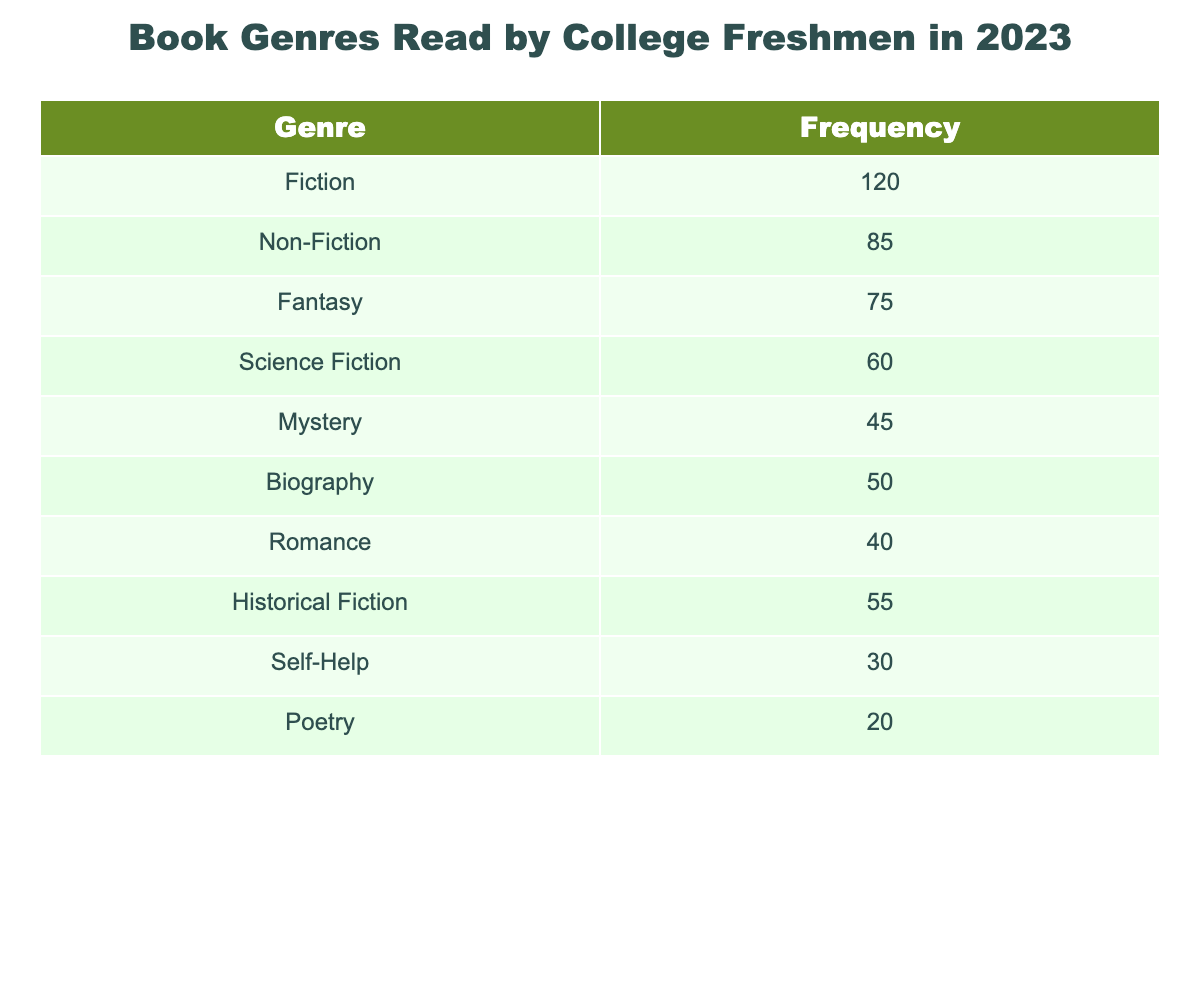What is the most read book genre by college freshmen in 2023? The table indicates that the genre with the highest frequency is Fiction with a total of 120.
Answer: Fiction How many freshmen read Non-Fiction books? The table provides the frequency for Non-Fiction, which is stated to be 85.
Answer: 85 Which genre has the lowest frequency of readers? From the table, Poetry has the lowest frequency of readers, with a total of 20.
Answer: Poetry What is the total number of freshmen that read Fiction and Mystery combined? To find the total, I add the frequencies of both genres: 120 (Fiction) + 45 (Mystery) = 165.
Answer: 165 Is the number of freshmen reading Historical Fiction greater than those reading Romance? The frequency for Historical Fiction is 55, and for Romance it is 40; since 55 is greater than 40, the answer is yes.
Answer: Yes What is the difference in frequency between the genres of Fantasy and Science Fiction? The frequency for Fantasy is 75, and for Science Fiction is 60. The difference is calculated by subtracting: 75 - 60 = 15.
Answer: 15 What percentage of the total books read are categorized as Self-Help? First, calculate the total frequency: 120 + 85 + 75 + 60 + 45 + 50 + 40 + 55 + 30 + 20 =  530. The frequency for Self-Help is 30; thus, the percentage is (30/530) * 100 ≈ 5.66%.
Answer: Approximately 5.66% If a student were to randomly pick one of the genres, what is the probability it would be a genre that is not Biography? First, the total number of genres is 10. The frequency for Biography is 50, and the remaining frequencies add up to 480 (530 - 50). The probability is thus 480/530 = 0.9057, or about 90.57%.
Answer: 90.57% How many more freshmen read Fiction than those who read Self-Help? Fiction has a frequency of 120 and Self-Help has 30; the difference is 120 - 30 = 90.
Answer: 90 What genres have a frequency of 50 or more, and how many are there? Looking at the table, the genres with a frequency of 50 or more are Fiction, Non-Fiction, Fantasy, Biography, Historical Fiction, and Science Fiction. That's a total of 6 genres.
Answer: 6 